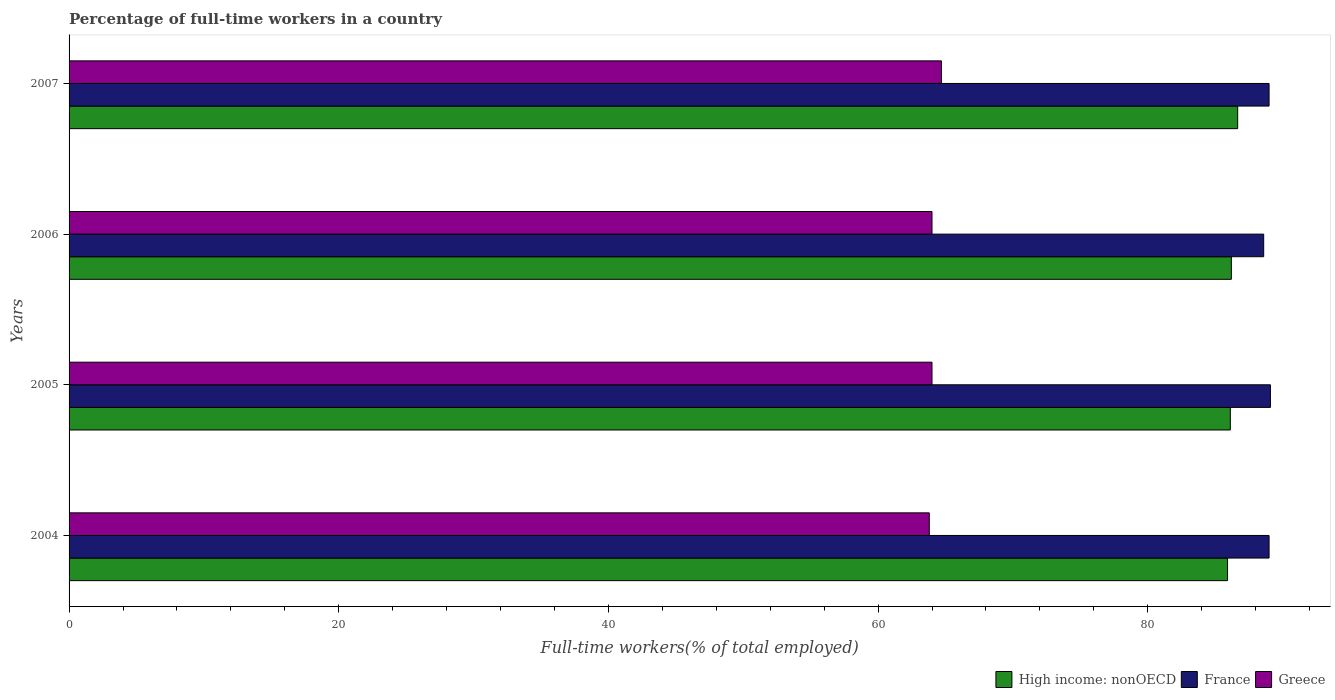How many different coloured bars are there?
Offer a very short reply. 3. Are the number of bars per tick equal to the number of legend labels?
Provide a short and direct response. Yes. What is the percentage of full-time workers in High income: nonOECD in 2005?
Your response must be concise. 86.13. Across all years, what is the maximum percentage of full-time workers in High income: nonOECD?
Your answer should be compact. 86.67. Across all years, what is the minimum percentage of full-time workers in France?
Provide a short and direct response. 88.6. In which year was the percentage of full-time workers in Greece maximum?
Provide a short and direct response. 2007. What is the total percentage of full-time workers in France in the graph?
Provide a short and direct response. 355.7. What is the difference between the percentage of full-time workers in High income: nonOECD in 2004 and that in 2006?
Offer a very short reply. -0.28. What is the difference between the percentage of full-time workers in Greece in 2005 and the percentage of full-time workers in High income: nonOECD in 2007?
Make the answer very short. -22.67. What is the average percentage of full-time workers in Greece per year?
Provide a short and direct response. 64.12. In the year 2005, what is the difference between the percentage of full-time workers in High income: nonOECD and percentage of full-time workers in Greece?
Offer a terse response. 22.13. In how many years, is the percentage of full-time workers in High income: nonOECD greater than 44 %?
Your answer should be very brief. 4. What is the ratio of the percentage of full-time workers in France in 2004 to that in 2005?
Your answer should be compact. 1. Is the difference between the percentage of full-time workers in High income: nonOECD in 2006 and 2007 greater than the difference between the percentage of full-time workers in Greece in 2006 and 2007?
Provide a short and direct response. Yes. What is the difference between the highest and the second highest percentage of full-time workers in France?
Make the answer very short. 0.1. What is the difference between the highest and the lowest percentage of full-time workers in High income: nonOECD?
Provide a succinct answer. 0.75. Is the sum of the percentage of full-time workers in France in 2004 and 2005 greater than the maximum percentage of full-time workers in Greece across all years?
Keep it short and to the point. Yes. What does the 1st bar from the top in 2004 represents?
Your response must be concise. Greece. How many years are there in the graph?
Your answer should be compact. 4. Does the graph contain grids?
Make the answer very short. No. How are the legend labels stacked?
Provide a succinct answer. Horizontal. What is the title of the graph?
Provide a short and direct response. Percentage of full-time workers in a country. What is the label or title of the X-axis?
Your response must be concise. Full-time workers(% of total employed). What is the Full-time workers(% of total employed) of High income: nonOECD in 2004?
Offer a very short reply. 85.92. What is the Full-time workers(% of total employed) in France in 2004?
Give a very brief answer. 89. What is the Full-time workers(% of total employed) in Greece in 2004?
Provide a short and direct response. 63.8. What is the Full-time workers(% of total employed) of High income: nonOECD in 2005?
Your response must be concise. 86.13. What is the Full-time workers(% of total employed) in France in 2005?
Make the answer very short. 89.1. What is the Full-time workers(% of total employed) of High income: nonOECD in 2006?
Offer a very short reply. 86.2. What is the Full-time workers(% of total employed) in France in 2006?
Your response must be concise. 88.6. What is the Full-time workers(% of total employed) in Greece in 2006?
Offer a terse response. 64. What is the Full-time workers(% of total employed) in High income: nonOECD in 2007?
Make the answer very short. 86.67. What is the Full-time workers(% of total employed) of France in 2007?
Provide a short and direct response. 89. What is the Full-time workers(% of total employed) in Greece in 2007?
Provide a succinct answer. 64.7. Across all years, what is the maximum Full-time workers(% of total employed) of High income: nonOECD?
Your response must be concise. 86.67. Across all years, what is the maximum Full-time workers(% of total employed) of France?
Provide a succinct answer. 89.1. Across all years, what is the maximum Full-time workers(% of total employed) of Greece?
Give a very brief answer. 64.7. Across all years, what is the minimum Full-time workers(% of total employed) of High income: nonOECD?
Give a very brief answer. 85.92. Across all years, what is the minimum Full-time workers(% of total employed) in France?
Ensure brevity in your answer.  88.6. Across all years, what is the minimum Full-time workers(% of total employed) of Greece?
Provide a succinct answer. 63.8. What is the total Full-time workers(% of total employed) of High income: nonOECD in the graph?
Your answer should be very brief. 344.92. What is the total Full-time workers(% of total employed) in France in the graph?
Give a very brief answer. 355.7. What is the total Full-time workers(% of total employed) of Greece in the graph?
Provide a succinct answer. 256.5. What is the difference between the Full-time workers(% of total employed) in High income: nonOECD in 2004 and that in 2005?
Your answer should be very brief. -0.21. What is the difference between the Full-time workers(% of total employed) in France in 2004 and that in 2005?
Offer a terse response. -0.1. What is the difference between the Full-time workers(% of total employed) of Greece in 2004 and that in 2005?
Keep it short and to the point. -0.2. What is the difference between the Full-time workers(% of total employed) in High income: nonOECD in 2004 and that in 2006?
Your answer should be very brief. -0.28. What is the difference between the Full-time workers(% of total employed) of France in 2004 and that in 2006?
Provide a succinct answer. 0.4. What is the difference between the Full-time workers(% of total employed) in High income: nonOECD in 2004 and that in 2007?
Provide a short and direct response. -0.75. What is the difference between the Full-time workers(% of total employed) in High income: nonOECD in 2005 and that in 2006?
Your answer should be very brief. -0.08. What is the difference between the Full-time workers(% of total employed) of Greece in 2005 and that in 2006?
Make the answer very short. 0. What is the difference between the Full-time workers(% of total employed) in High income: nonOECD in 2005 and that in 2007?
Your response must be concise. -0.54. What is the difference between the Full-time workers(% of total employed) in High income: nonOECD in 2006 and that in 2007?
Your answer should be very brief. -0.47. What is the difference between the Full-time workers(% of total employed) of Greece in 2006 and that in 2007?
Your answer should be compact. -0.7. What is the difference between the Full-time workers(% of total employed) in High income: nonOECD in 2004 and the Full-time workers(% of total employed) in France in 2005?
Offer a terse response. -3.18. What is the difference between the Full-time workers(% of total employed) in High income: nonOECD in 2004 and the Full-time workers(% of total employed) in Greece in 2005?
Provide a short and direct response. 21.92. What is the difference between the Full-time workers(% of total employed) of High income: nonOECD in 2004 and the Full-time workers(% of total employed) of France in 2006?
Your answer should be very brief. -2.68. What is the difference between the Full-time workers(% of total employed) of High income: nonOECD in 2004 and the Full-time workers(% of total employed) of Greece in 2006?
Offer a terse response. 21.92. What is the difference between the Full-time workers(% of total employed) in France in 2004 and the Full-time workers(% of total employed) in Greece in 2006?
Give a very brief answer. 25. What is the difference between the Full-time workers(% of total employed) of High income: nonOECD in 2004 and the Full-time workers(% of total employed) of France in 2007?
Offer a very short reply. -3.08. What is the difference between the Full-time workers(% of total employed) of High income: nonOECD in 2004 and the Full-time workers(% of total employed) of Greece in 2007?
Offer a very short reply. 21.22. What is the difference between the Full-time workers(% of total employed) in France in 2004 and the Full-time workers(% of total employed) in Greece in 2007?
Offer a terse response. 24.3. What is the difference between the Full-time workers(% of total employed) of High income: nonOECD in 2005 and the Full-time workers(% of total employed) of France in 2006?
Keep it short and to the point. -2.47. What is the difference between the Full-time workers(% of total employed) of High income: nonOECD in 2005 and the Full-time workers(% of total employed) of Greece in 2006?
Keep it short and to the point. 22.13. What is the difference between the Full-time workers(% of total employed) in France in 2005 and the Full-time workers(% of total employed) in Greece in 2006?
Keep it short and to the point. 25.1. What is the difference between the Full-time workers(% of total employed) in High income: nonOECD in 2005 and the Full-time workers(% of total employed) in France in 2007?
Make the answer very short. -2.87. What is the difference between the Full-time workers(% of total employed) in High income: nonOECD in 2005 and the Full-time workers(% of total employed) in Greece in 2007?
Provide a succinct answer. 21.43. What is the difference between the Full-time workers(% of total employed) in France in 2005 and the Full-time workers(% of total employed) in Greece in 2007?
Your response must be concise. 24.4. What is the difference between the Full-time workers(% of total employed) in High income: nonOECD in 2006 and the Full-time workers(% of total employed) in France in 2007?
Provide a short and direct response. -2.8. What is the difference between the Full-time workers(% of total employed) of High income: nonOECD in 2006 and the Full-time workers(% of total employed) of Greece in 2007?
Give a very brief answer. 21.5. What is the difference between the Full-time workers(% of total employed) of France in 2006 and the Full-time workers(% of total employed) of Greece in 2007?
Provide a succinct answer. 23.9. What is the average Full-time workers(% of total employed) in High income: nonOECD per year?
Offer a very short reply. 86.23. What is the average Full-time workers(% of total employed) of France per year?
Provide a succinct answer. 88.92. What is the average Full-time workers(% of total employed) of Greece per year?
Your response must be concise. 64.12. In the year 2004, what is the difference between the Full-time workers(% of total employed) of High income: nonOECD and Full-time workers(% of total employed) of France?
Keep it short and to the point. -3.08. In the year 2004, what is the difference between the Full-time workers(% of total employed) of High income: nonOECD and Full-time workers(% of total employed) of Greece?
Your answer should be compact. 22.12. In the year 2004, what is the difference between the Full-time workers(% of total employed) of France and Full-time workers(% of total employed) of Greece?
Your answer should be compact. 25.2. In the year 2005, what is the difference between the Full-time workers(% of total employed) in High income: nonOECD and Full-time workers(% of total employed) in France?
Make the answer very short. -2.97. In the year 2005, what is the difference between the Full-time workers(% of total employed) in High income: nonOECD and Full-time workers(% of total employed) in Greece?
Your answer should be very brief. 22.13. In the year 2005, what is the difference between the Full-time workers(% of total employed) of France and Full-time workers(% of total employed) of Greece?
Offer a terse response. 25.1. In the year 2006, what is the difference between the Full-time workers(% of total employed) in High income: nonOECD and Full-time workers(% of total employed) in France?
Give a very brief answer. -2.4. In the year 2006, what is the difference between the Full-time workers(% of total employed) of High income: nonOECD and Full-time workers(% of total employed) of Greece?
Make the answer very short. 22.2. In the year 2006, what is the difference between the Full-time workers(% of total employed) of France and Full-time workers(% of total employed) of Greece?
Provide a succinct answer. 24.6. In the year 2007, what is the difference between the Full-time workers(% of total employed) of High income: nonOECD and Full-time workers(% of total employed) of France?
Your answer should be compact. -2.33. In the year 2007, what is the difference between the Full-time workers(% of total employed) of High income: nonOECD and Full-time workers(% of total employed) of Greece?
Give a very brief answer. 21.97. In the year 2007, what is the difference between the Full-time workers(% of total employed) in France and Full-time workers(% of total employed) in Greece?
Keep it short and to the point. 24.3. What is the ratio of the Full-time workers(% of total employed) of France in 2004 to that in 2005?
Offer a terse response. 1. What is the ratio of the Full-time workers(% of total employed) of High income: nonOECD in 2004 to that in 2006?
Your answer should be very brief. 1. What is the ratio of the Full-time workers(% of total employed) in High income: nonOECD in 2004 to that in 2007?
Keep it short and to the point. 0.99. What is the ratio of the Full-time workers(% of total employed) in Greece in 2004 to that in 2007?
Make the answer very short. 0.99. What is the ratio of the Full-time workers(% of total employed) of France in 2005 to that in 2006?
Ensure brevity in your answer.  1.01. What is the ratio of the Full-time workers(% of total employed) in France in 2005 to that in 2007?
Provide a succinct answer. 1. What is the ratio of the Full-time workers(% of total employed) in Greece in 2005 to that in 2007?
Give a very brief answer. 0.99. What is the ratio of the Full-time workers(% of total employed) in High income: nonOECD in 2006 to that in 2007?
Provide a succinct answer. 0.99. What is the ratio of the Full-time workers(% of total employed) in France in 2006 to that in 2007?
Your answer should be very brief. 1. What is the ratio of the Full-time workers(% of total employed) of Greece in 2006 to that in 2007?
Your answer should be very brief. 0.99. What is the difference between the highest and the second highest Full-time workers(% of total employed) of High income: nonOECD?
Make the answer very short. 0.47. What is the difference between the highest and the second highest Full-time workers(% of total employed) in France?
Your answer should be compact. 0.1. What is the difference between the highest and the lowest Full-time workers(% of total employed) in High income: nonOECD?
Offer a very short reply. 0.75. 